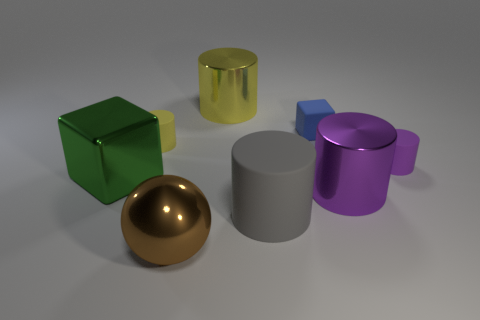Subtract all gray cylinders. How many cylinders are left? 4 Subtract all tiny purple rubber cylinders. How many cylinders are left? 4 Subtract all red cylinders. Subtract all yellow spheres. How many cylinders are left? 5 Add 2 small purple objects. How many objects exist? 10 Subtract all spheres. How many objects are left? 7 Add 5 blue matte objects. How many blue matte objects exist? 6 Subtract 2 purple cylinders. How many objects are left? 6 Subtract all big purple objects. Subtract all large gray cylinders. How many objects are left? 6 Add 2 big purple shiny things. How many big purple shiny things are left? 3 